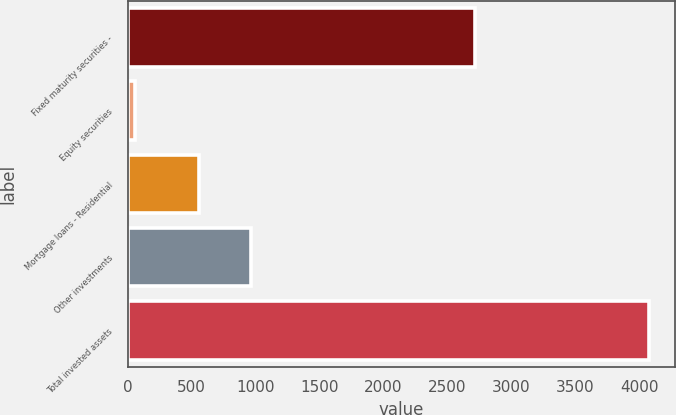Convert chart. <chart><loc_0><loc_0><loc_500><loc_500><bar_chart><fcel>Fixed maturity securities -<fcel>Equity securities<fcel>Mortgage loans - Residential<fcel>Other investments<fcel>Total invested assets<nl><fcel>2719.5<fcel>52.7<fcel>558.6<fcel>961.04<fcel>4077.1<nl></chart> 